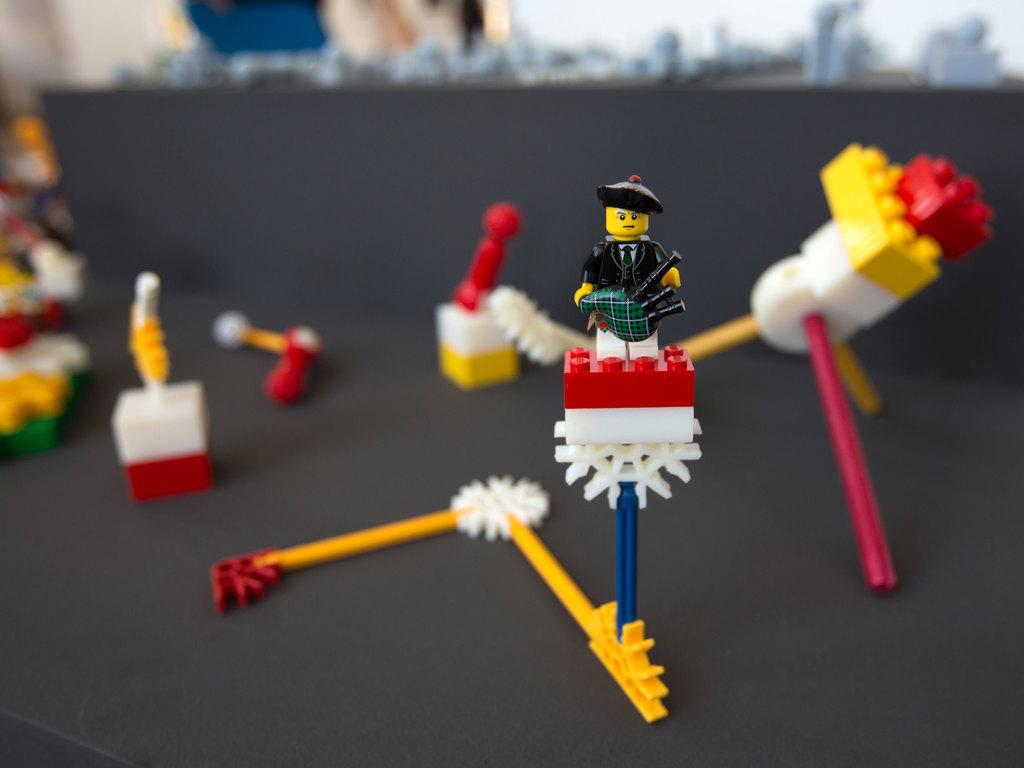What is located in the middle of the image? There are dolls in the middle of the image. What type of cave can be seen in the background of the image? There is no cave present in the image; it only features dolls in the middle. 